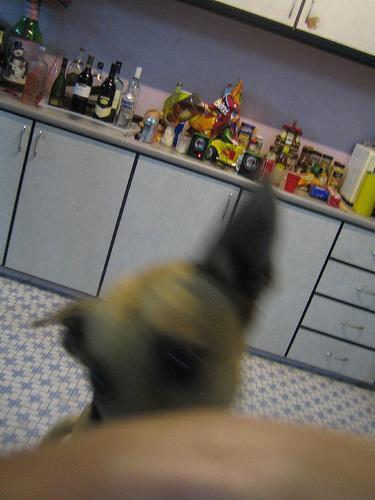How many cats do you see?
Give a very brief answer. 0. How many dogs are in the picture?
Give a very brief answer. 1. 